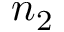Convert formula to latex. <formula><loc_0><loc_0><loc_500><loc_500>n _ { 2 }</formula> 